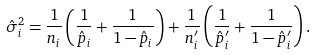<formula> <loc_0><loc_0><loc_500><loc_500>\hat { \sigma } _ { i } ^ { 2 } = \frac { 1 } { n _ { i } } \left ( \frac { 1 } { \hat { p } _ { i } } + \frac { 1 } { 1 - \hat { p } _ { i } } \right ) + \frac { 1 } { n _ { i } ^ { \prime } } \left ( \frac { 1 } { \hat { p } _ { i } ^ { \prime } } + \frac { 1 } { 1 - \hat { p } _ { i } ^ { \prime } } \right ) .</formula> 